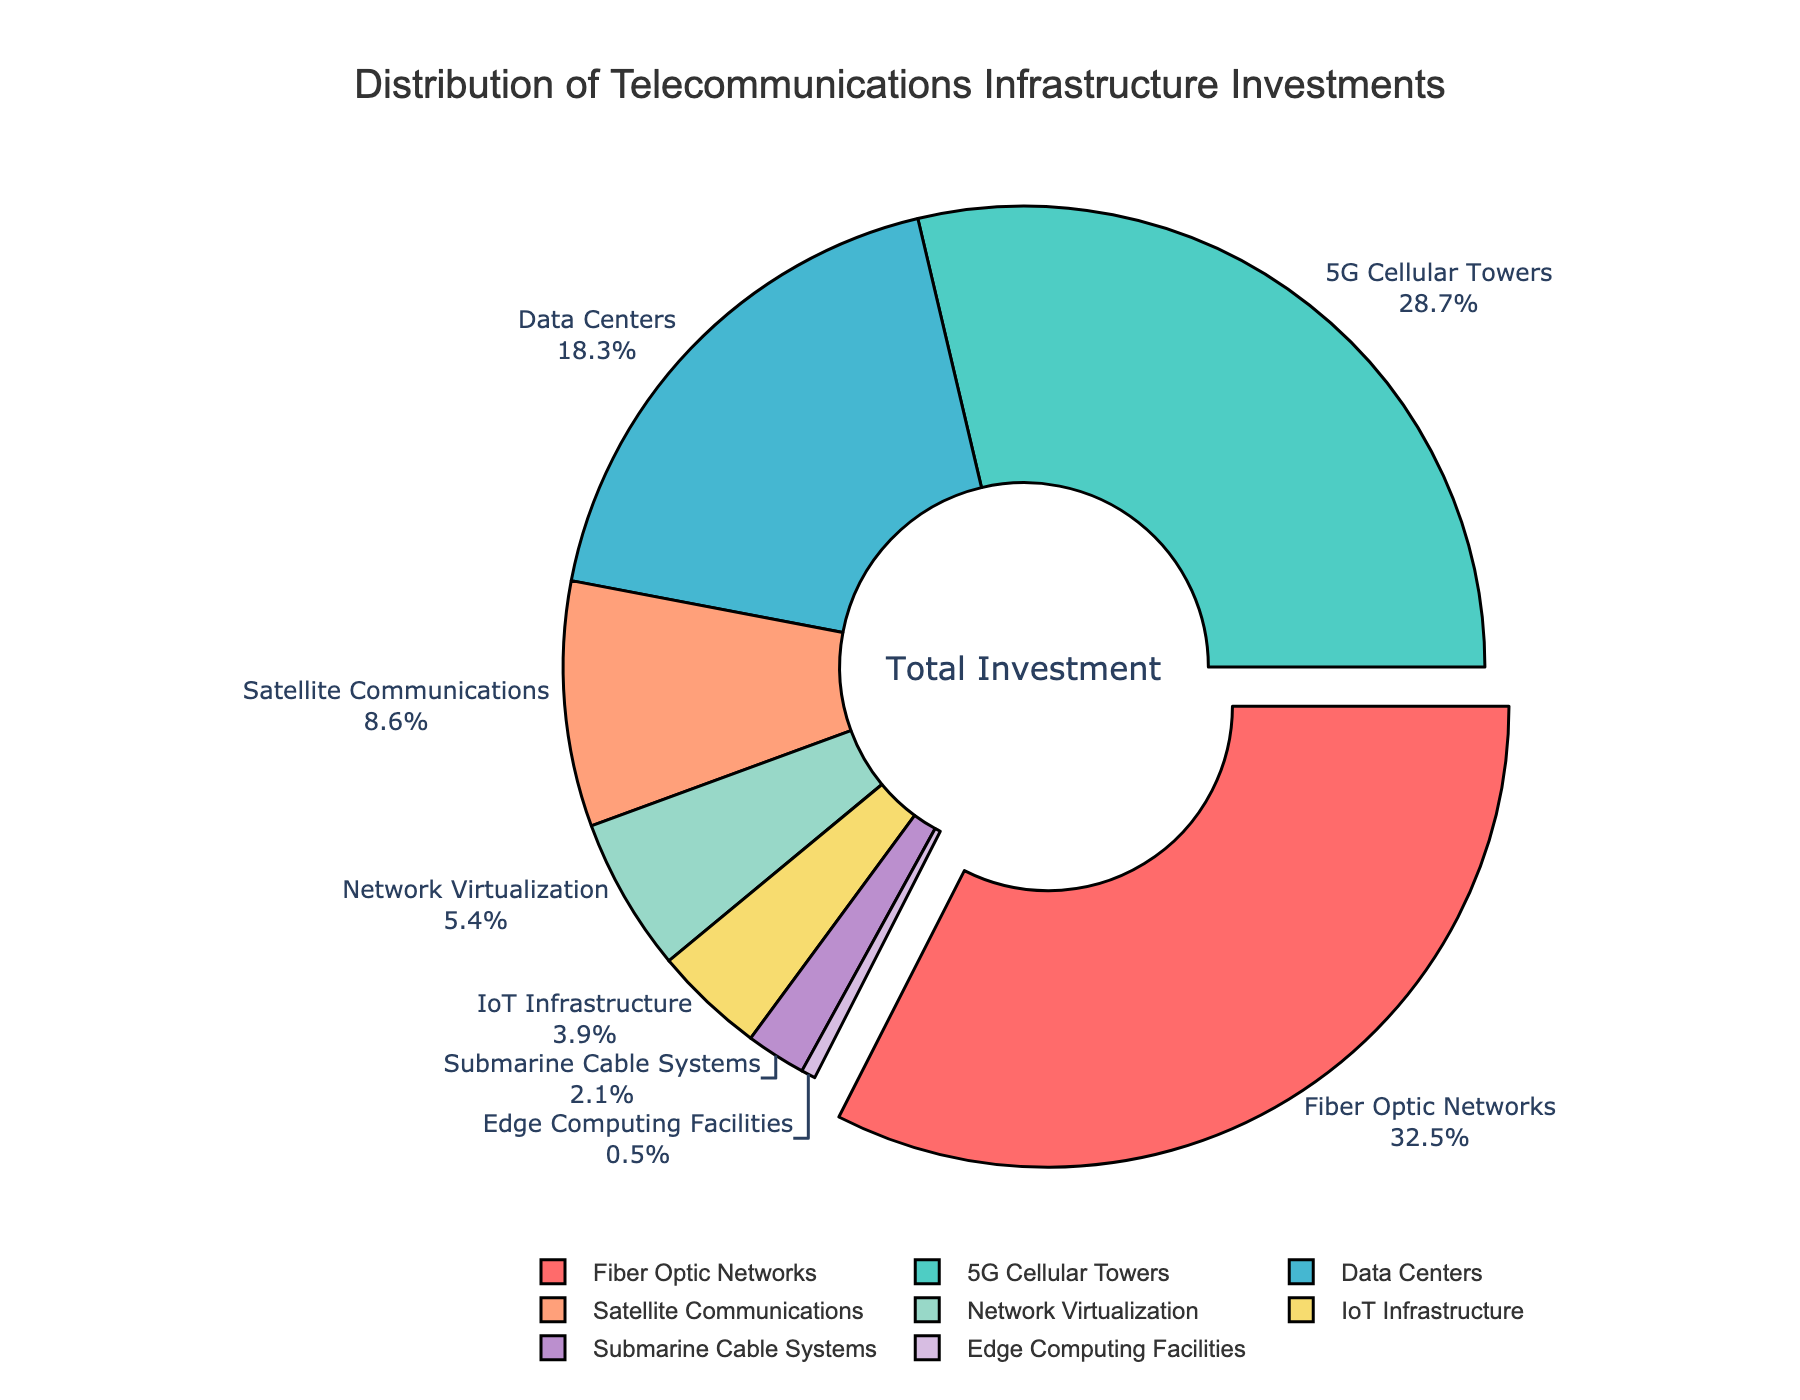What is the sector with the highest investment percentage? The sector with the highest investment can be identified by looking for the segment of the pie chart that has the largest percentage value. In this case, Fiber Optic Networks is labeled with 32.5%, which is the highest.
Answer: Fiber Optic Networks What is the combined investment percentage for Fiber Optic Networks and Data Centers? To find the combined percentage, sum the investment percentages for Fiber Optic Networks and Data Centers: 32.5% + 18.3% = 50.8%.
Answer: 50.8% Compare the investment percentages for 5G Cellular Towers and Satellite Communications. Which sector receives more investment and by how much? 5G Cellular Towers have an investment percentage of 28.7%, while Satellite Communications have 8.6%. The difference is 28.7% - 8.6% = 20.1%, with 5G Cellular Towers receiving more investment.
Answer: 5G Cellular Towers by 20.1% Which sector has the smallest investment percentage, and what is that percentage? The smallest segment in the pie chart corresponds to the sector with the smallest investment. Edge Computing Facilities is labeled with a 0.5% investment, which is the smallest.
Answer: Edge Computing Facilities, 0.5% What is the total investment percentage for sectors contributing less than 5% each? Identify sectors with investments less than 5% and sum their percentages: Satellite Communications (8.6%) is above 5%, while Network Virtualization (5.4%), IoT Infrastructure (3.9%), Submarine Cable Systems (2.1%), and Edge Computing Facilities (0.5%) are below 5%. The total is 5.4% + 3.9% + 2.1% + 0.5% = 11.9%.
Answer: 11.9% Is the investment in Fiber Optic Networks greater than the combined investment in IoT Infrastructure and Submarine Cable Systems? Compare the percentage for Fiber Optic Networks (32.5%) with the sum of IoT Infrastructure (3.9%) and Submarine Cable Systems (2.1%): 3.9% + 2.1% = 6.0%. Since 32.5% is greater than 6.0%, Fiber Optic Networks have a greater investment.
Answer: Yes What is the median investment percentage of the sectors? Arrange the percentages in ascending order: 0.5%, 2.1%, 3.9%, 5.4%, 8.6%, 18.3%, 28.7%, 32.5%. The median is the average of the 4th and 5th values: (5.4% + 8.6%) / 2 = 7.0%.
Answer: 7.0% How does the investment in Network Virtualization compare to that in Data Centers? Network Virtualization has an investment percentage of 5.4%, while Data Centers have 18.3%. By comparing these values, Data Centers have a higher investment percentage, 18.3% - 5.4% = 12.9% more.
Answer: Data Centers by 12.9% What color is the segment representing Fiber Optic Networks? Each sector is color-coded in the pie chart. According to the provided color scale and description, the segment for Fiber Optic Networks is colored in red.
Answer: Red 